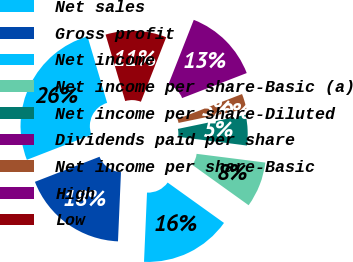Convert chart to OTSL. <chart><loc_0><loc_0><loc_500><loc_500><pie_chart><fcel>Net sales<fcel>Gross profit<fcel>Net income<fcel>Net income per share-Basic (a)<fcel>Net income per share-Diluted<fcel>Dividends paid per share<fcel>Net income per share-Basic<fcel>High<fcel>Low<nl><fcel>26.32%<fcel>18.42%<fcel>15.79%<fcel>7.89%<fcel>5.26%<fcel>0.0%<fcel>2.63%<fcel>13.16%<fcel>10.53%<nl></chart> 